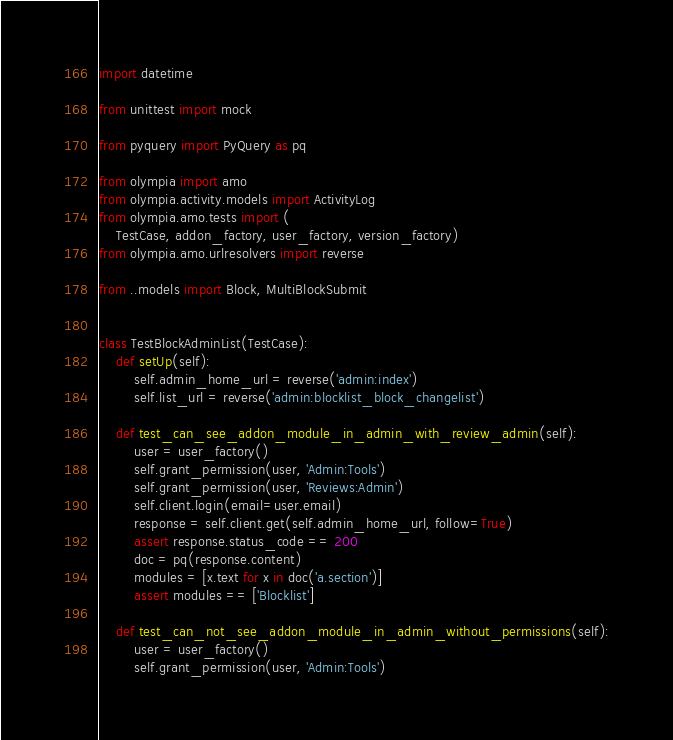<code> <loc_0><loc_0><loc_500><loc_500><_Python_>import datetime

from unittest import mock

from pyquery import PyQuery as pq

from olympia import amo
from olympia.activity.models import ActivityLog
from olympia.amo.tests import (
    TestCase, addon_factory, user_factory, version_factory)
from olympia.amo.urlresolvers import reverse

from ..models import Block, MultiBlockSubmit


class TestBlockAdminList(TestCase):
    def setUp(self):
        self.admin_home_url = reverse('admin:index')
        self.list_url = reverse('admin:blocklist_block_changelist')

    def test_can_see_addon_module_in_admin_with_review_admin(self):
        user = user_factory()
        self.grant_permission(user, 'Admin:Tools')
        self.grant_permission(user, 'Reviews:Admin')
        self.client.login(email=user.email)
        response = self.client.get(self.admin_home_url, follow=True)
        assert response.status_code == 200
        doc = pq(response.content)
        modules = [x.text for x in doc('a.section')]
        assert modules == ['Blocklist']

    def test_can_not_see_addon_module_in_admin_without_permissions(self):
        user = user_factory()
        self.grant_permission(user, 'Admin:Tools')</code> 